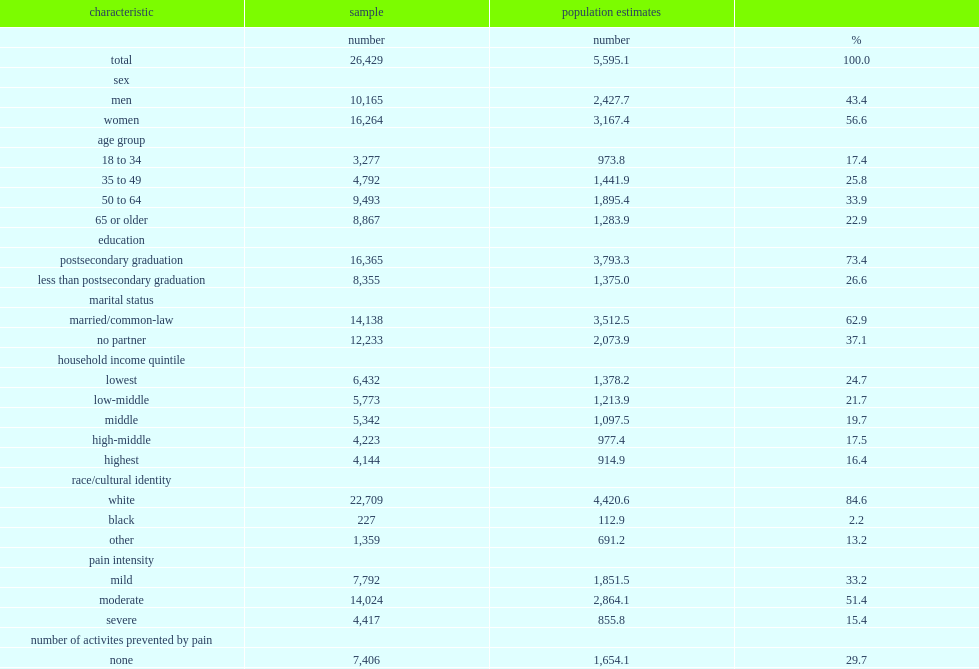How many respondents did further analysis focus on the subpopulation who reported chronic pain? 26429.0. How mnay people did further analysis focused on the subpopulation who reported chronic pain represent? 5595.1. 